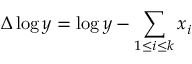Convert formula to latex. <formula><loc_0><loc_0><loc_500><loc_500>\Delta \log y = \log y - \sum _ { 1 \leq i \leq k } x _ { i }</formula> 